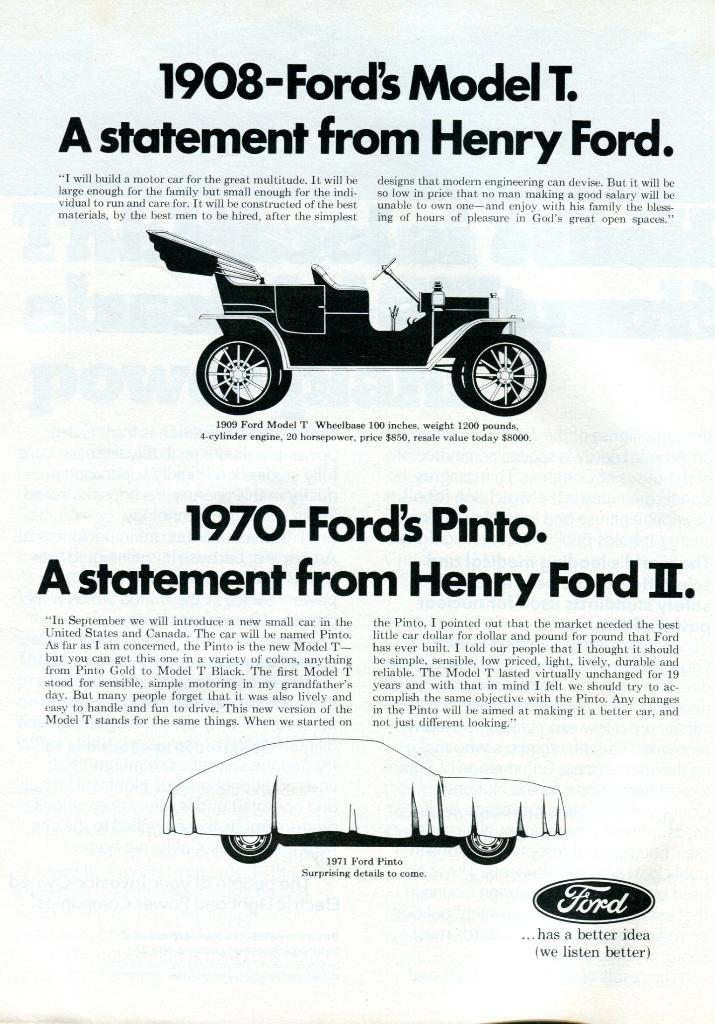What is depicted on the page in the image? The page contains vehicle sketches. What else can be found on the page besides the sketches? There is text on the page. What type of book might this page belong to? It could be a book about vehicles or a sketchbook with vehicle designs. Can you see any animals on the trail in the image? There is no trail or animal present in the image; it features a page from a book with vehicle sketches and text. 